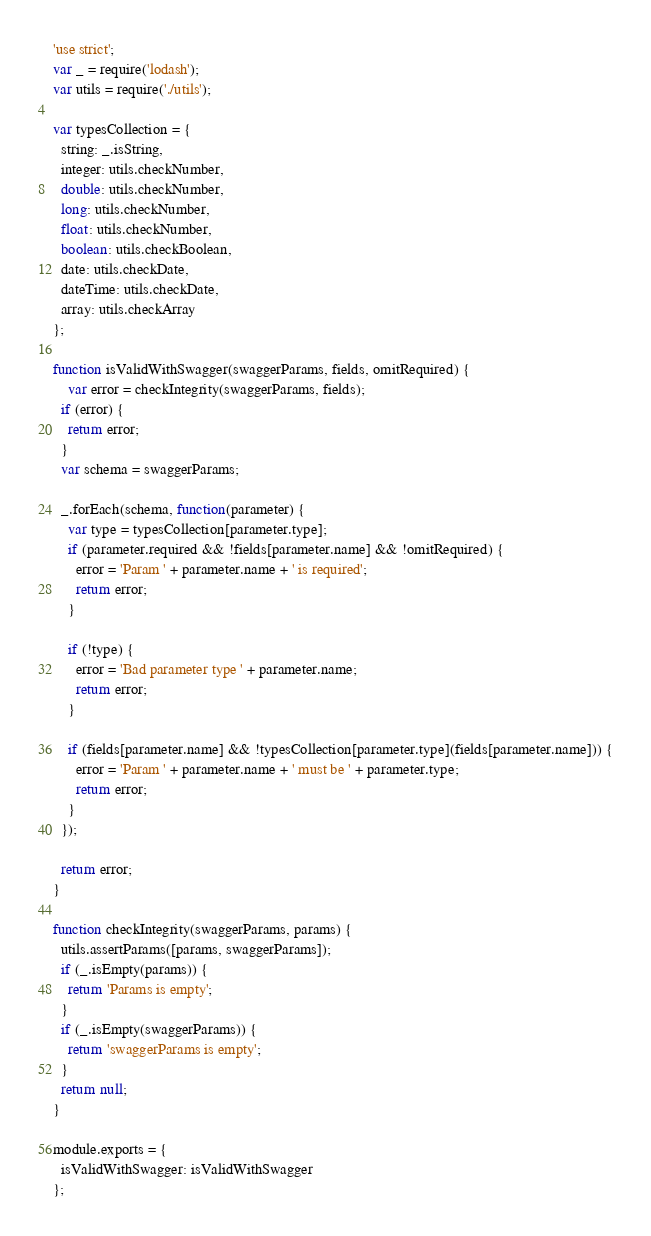Convert code to text. <code><loc_0><loc_0><loc_500><loc_500><_JavaScript_>'use strict';
var _ = require('lodash');
var utils = require('./utils');

var typesCollection = {
  string: _.isString,
  integer: utils.checkNumber,
  double: utils.checkNumber,
  long: utils.checkNumber,
  float: utils.checkNumber,
  boolean: utils.checkBoolean,
  date: utils.checkDate,
  dateTime: utils.checkDate,
  array: utils.checkArray
};

function isValidWithSwagger(swaggerParams, fields, omitRequired) {
	var error = checkIntegrity(swaggerParams, fields);
  if (error) {
    return error;
  }
  var schema = swaggerParams;

  _.forEach(schema, function(parameter) {
    var type = typesCollection[parameter.type];
    if (parameter.required && !fields[parameter.name] && !omitRequired) {
      error = 'Param ' + parameter.name + ' is required';
      return error;
    }

    if (!type) {
      error = 'Bad parameter type ' + parameter.name;
      return error;
    }

    if (fields[parameter.name] && !typesCollection[parameter.type](fields[parameter.name])) {
      error = 'Param ' + parameter.name + ' must be ' + parameter.type;
      return error;
    }
  });

  return error;
}

function checkIntegrity(swaggerParams, params) {
  utils.assertParams([params, swaggerParams]);
  if (_.isEmpty(params)) {
    return 'Params is empty';
  }
  if (_.isEmpty(swaggerParams)) { 
    return 'swaggerParams is empty';
  }
  return null;
}

module.exports = {
  isValidWithSwagger: isValidWithSwagger
};
</code> 